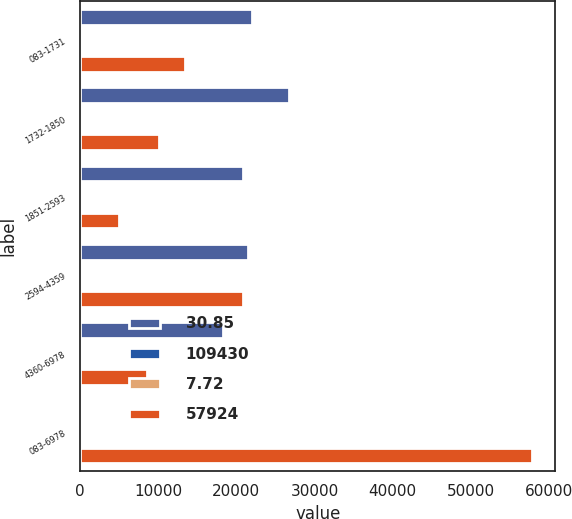Convert chart to OTSL. <chart><loc_0><loc_0><loc_500><loc_500><stacked_bar_chart><ecel><fcel>083-1731<fcel>1732-1850<fcel>1851-2593<fcel>2594-4359<fcel>4360-6978<fcel>083-6978<nl><fcel>30.85<fcel>22000<fcel>26785<fcel>20851<fcel>21492<fcel>18302<fcel>49.64<nl><fcel>109430<fcel>6.63<fcel>8.32<fcel>8.86<fcel>7.27<fcel>7.37<fcel>7.72<nl><fcel>7.72<fcel>14.26<fcel>18.4<fcel>21.35<fcel>42.92<fcel>49.64<fcel>28.17<nl><fcel>57924<fcel>13459<fcel>10138<fcel>4902<fcel>20896<fcel>8529<fcel>57924<nl></chart> 